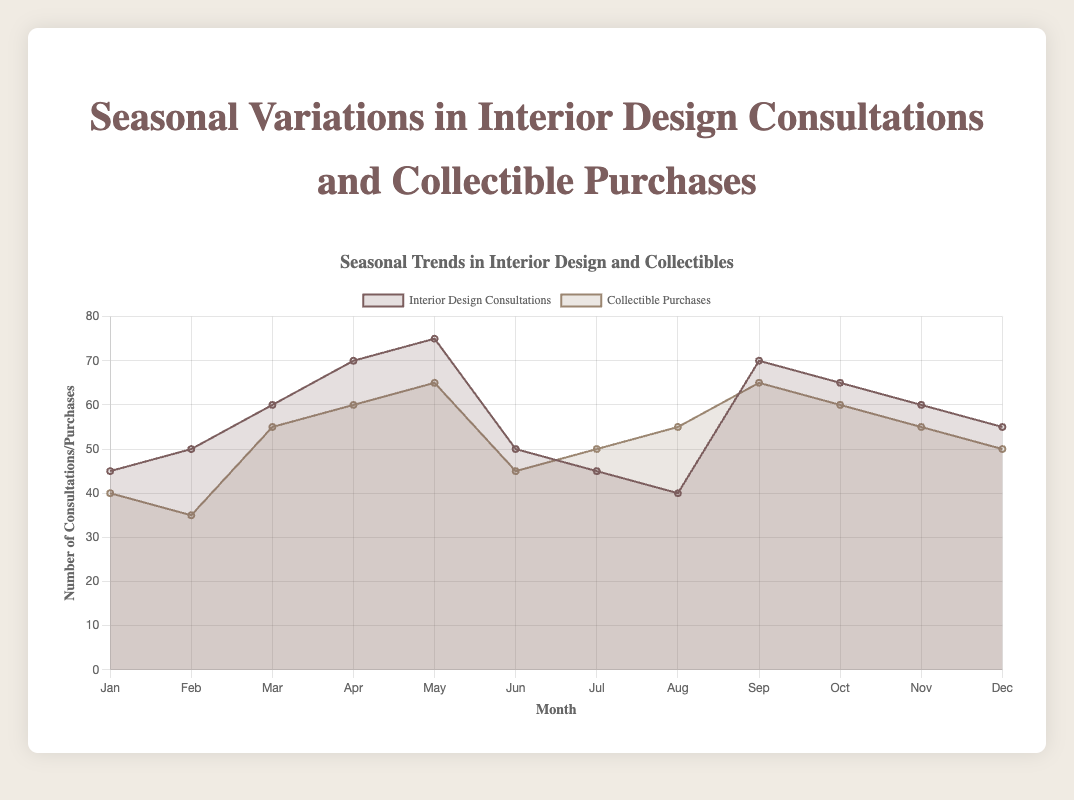What's the main trend in interior design consultations from January to December? The trend shows an increase in consultations during the spring and fall months, with peaks in May and September. The summer months see a decline, with the lowest number in August.
Answer: Increase in spring and fall, decline in summer Which month has the highest number of collectible purchases? To determine this, we look at the highest point on the 'Collectible Purchases' line. May shows the highest value of 65 purchases.
Answer: May Compare the number of interior design consultations and collectible purchases in February. Interior design consultations are plotted at 50, while collectible purchases are at 35. Comparing these two values shows that consultations are higher.
Answer: Consultations are higher How do the trends in interior design consultations and collectible purchases compare in the summer season? During summer (June, July, August), interior design consultations decrease from 50 to 40, whereas collectible purchases increase from 45 to 55. This shows a contrasting trend.
Answer: Consultations decrease, purchases increase In which season do interior design consultations peak? The peak of interior design consultations occurs in May, which is part of the spring season. Hence, the highest consultations are observed in spring.
Answer: Spring What is the average number of interior design consultations between June and August? The consultations in June, July, and August are 50, 45, and 40 respectively. Calculating the average: (50 + 45 + 40) / 3 = 45.
Answer: 45 What is the difference in the number of consultations between the highest and lowest months? The highest number of consultations is in May (75) and the lowest in August (40). The difference is 75 - 40 = 35.
Answer: 35 During which month is the number of collectible purchases equal to the number of interior design consultations? By examining the chart, in September, both collectible purchases and interior design consultations are equal at 70.
Answer: September How many months have higher collectible purchases than consultations? By comparing the values for each month, March, July, and August are the months where collectible purchases exceed consultations (55 vs 60 in March, 50 vs 45 in July, and 55 vs 40 in August).
Answer: 3 months Describe the overall seasonal trend in collectible purchases. Collectible purchases gradually increase from winter to spring, slightly decrease in summer, and then slightly increase again in fall.
Answer: Increase in spring, slight decrease in summer, slight increase in fall 